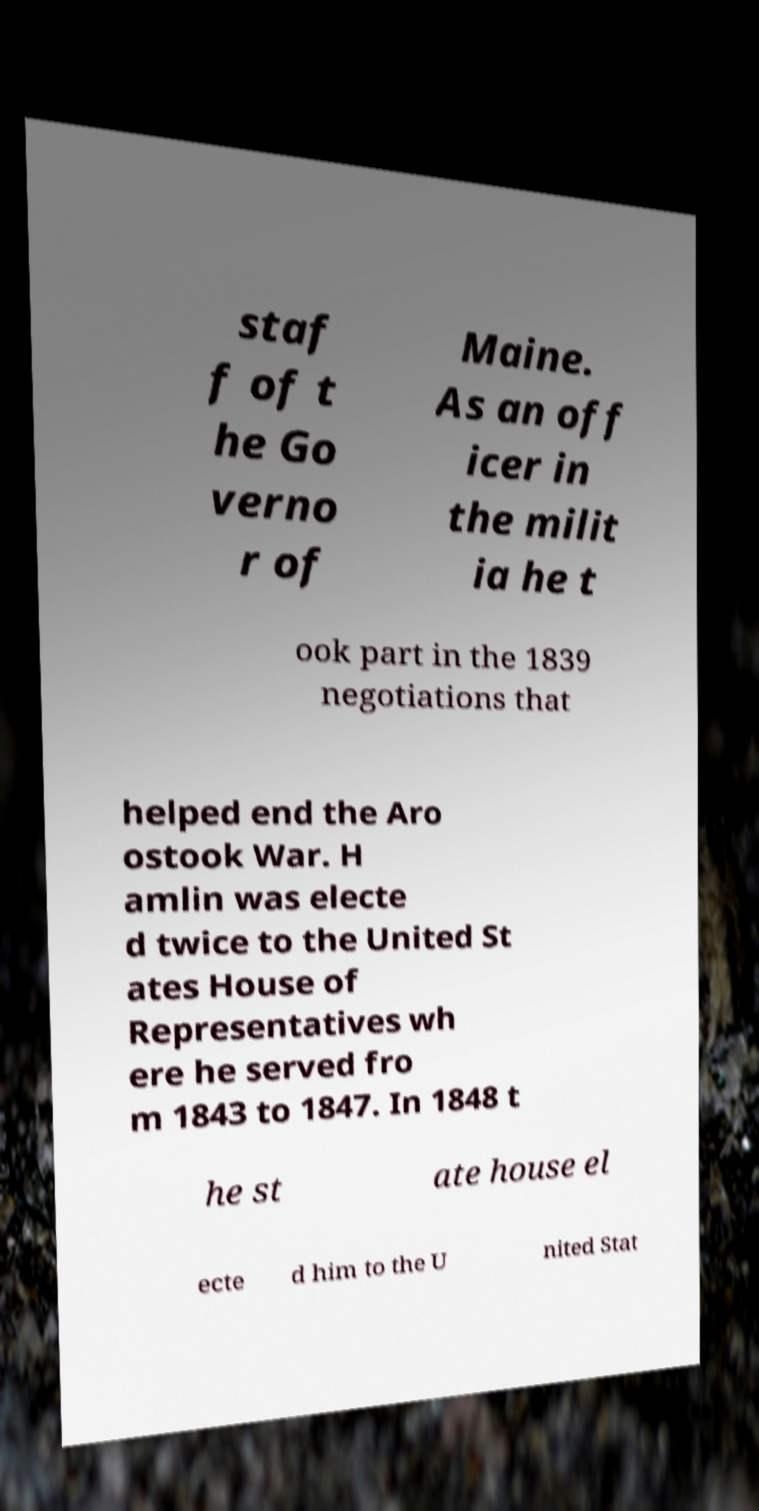For documentation purposes, I need the text within this image transcribed. Could you provide that? staf f of t he Go verno r of Maine. As an off icer in the milit ia he t ook part in the 1839 negotiations that helped end the Aro ostook War. H amlin was electe d twice to the United St ates House of Representatives wh ere he served fro m 1843 to 1847. In 1848 t he st ate house el ecte d him to the U nited Stat 